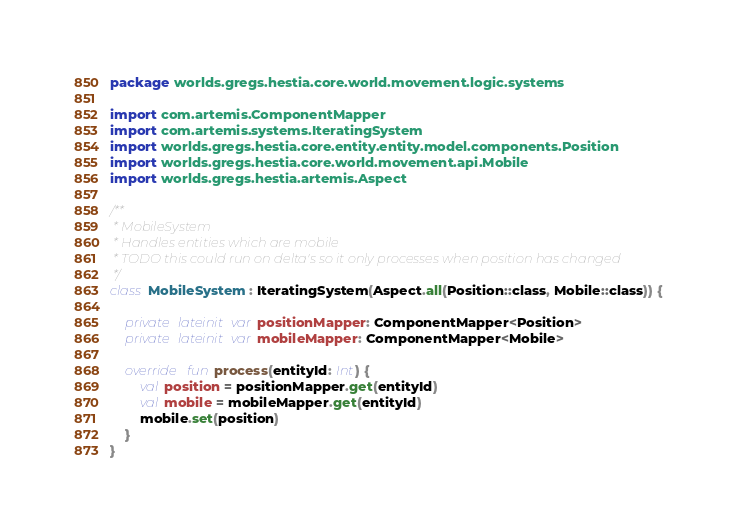Convert code to text. <code><loc_0><loc_0><loc_500><loc_500><_Kotlin_>package worlds.gregs.hestia.core.world.movement.logic.systems

import com.artemis.ComponentMapper
import com.artemis.systems.IteratingSystem
import worlds.gregs.hestia.core.entity.entity.model.components.Position
import worlds.gregs.hestia.core.world.movement.api.Mobile
import worlds.gregs.hestia.artemis.Aspect

/**
 * MobileSystem
 * Handles entities which are mobile
 * TODO this could run on delta's so it only processes when position has changed
 */
class MobileSystem : IteratingSystem(Aspect.all(Position::class, Mobile::class)) {

    private lateinit var positionMapper: ComponentMapper<Position>
    private lateinit var mobileMapper: ComponentMapper<Mobile>

    override fun process(entityId: Int) {
        val position = positionMapper.get(entityId)
        val mobile = mobileMapper.get(entityId)
        mobile.set(position)
    }
}</code> 